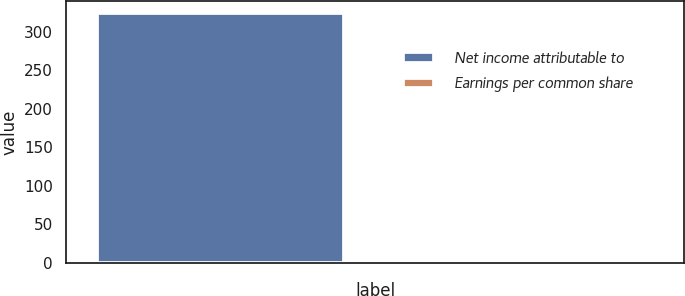Convert chart. <chart><loc_0><loc_0><loc_500><loc_500><bar_chart><fcel>Net income attributable to<fcel>Earnings per common share<nl><fcel>323.9<fcel>2.27<nl></chart> 